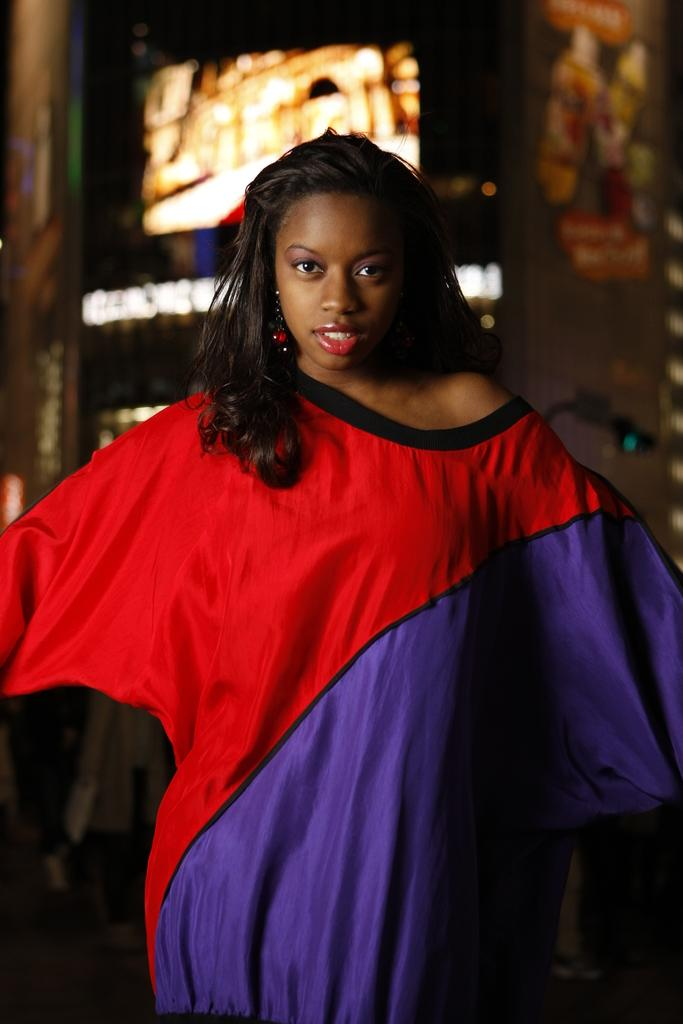What is the main subject of the image? There is a woman standing in the image. Can you describe the background of the image? There are lights visible in the background of the image. What type of soap is being advertised in the image? There is no advertisement or soap present in the image; it features a woman standing with lights in the background. How does the woman's digestion appear to be in the image? There is no information about the woman's digestion in the image, as it only shows her standing with lights in the background. 